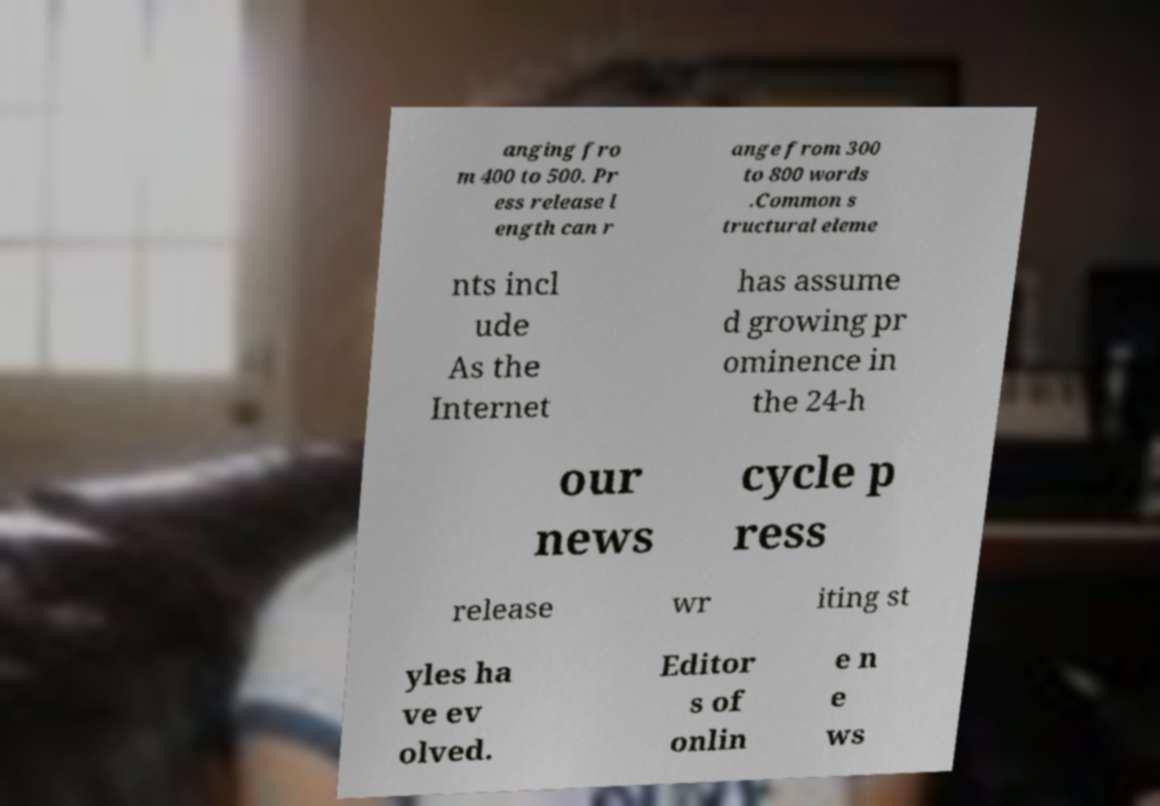Could you assist in decoding the text presented in this image and type it out clearly? anging fro m 400 to 500. Pr ess release l ength can r ange from 300 to 800 words .Common s tructural eleme nts incl ude As the Internet has assume d growing pr ominence in the 24-h our news cycle p ress release wr iting st yles ha ve ev olved. Editor s of onlin e n e ws 